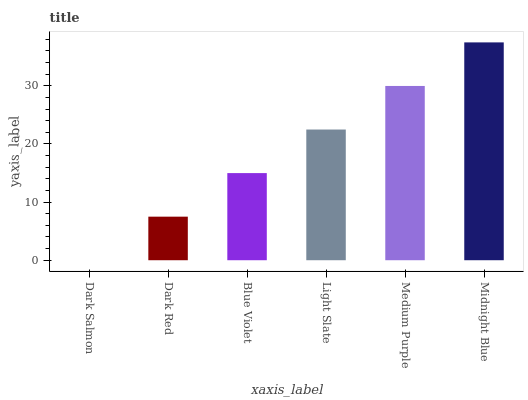Is Dark Salmon the minimum?
Answer yes or no. Yes. Is Midnight Blue the maximum?
Answer yes or no. Yes. Is Dark Red the minimum?
Answer yes or no. No. Is Dark Red the maximum?
Answer yes or no. No. Is Dark Red greater than Dark Salmon?
Answer yes or no. Yes. Is Dark Salmon less than Dark Red?
Answer yes or no. Yes. Is Dark Salmon greater than Dark Red?
Answer yes or no. No. Is Dark Red less than Dark Salmon?
Answer yes or no. No. Is Light Slate the high median?
Answer yes or no. Yes. Is Blue Violet the low median?
Answer yes or no. Yes. Is Dark Red the high median?
Answer yes or no. No. Is Dark Red the low median?
Answer yes or no. No. 